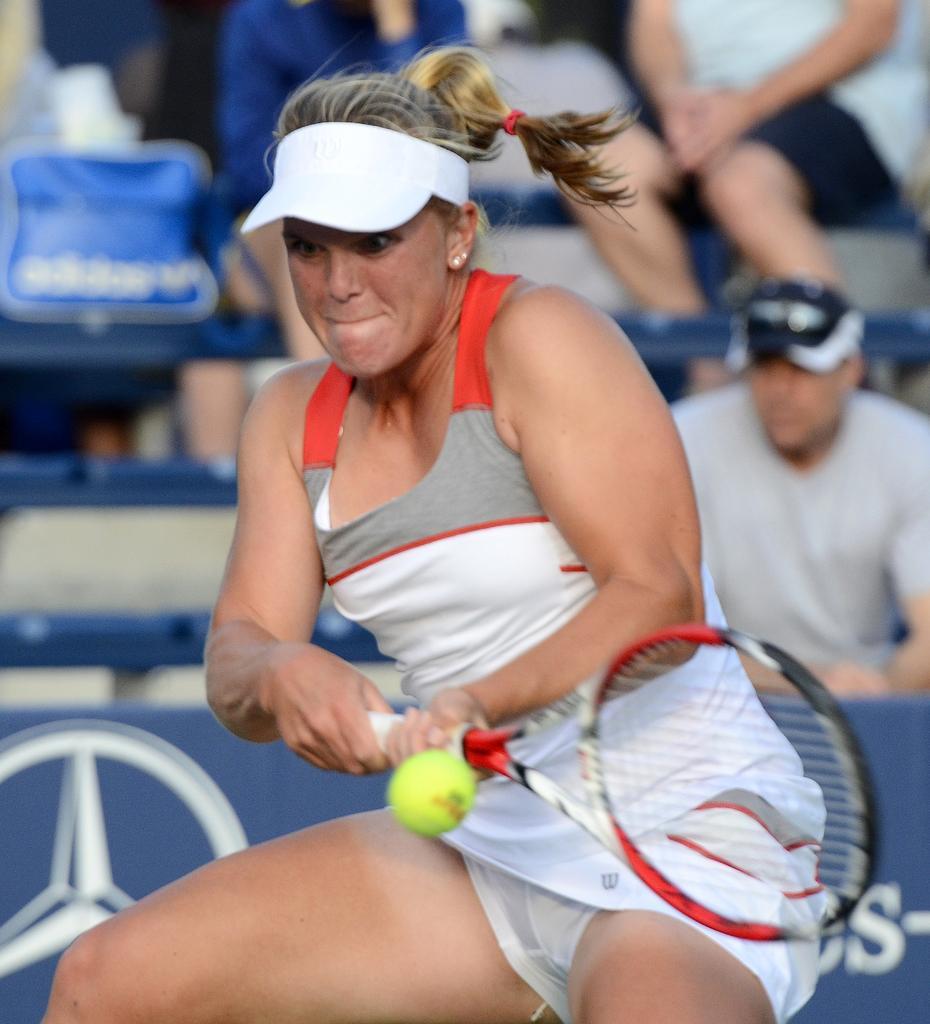Please provide a concise description of this image. In this image i can see a woman is holding a bat and hitting a ball. 